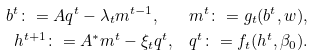Convert formula to latex. <formula><loc_0><loc_0><loc_500><loc_500>b ^ { t } \colon = A q ^ { t } - \lambda _ { t } m ^ { t - 1 } , \quad & m ^ { t } \colon = g _ { t } ( b ^ { t } , w ) , \\ h ^ { t + 1 } \colon = A ^ { * } m ^ { t } - \xi _ { t } q ^ { t } , \quad & q ^ { t } \colon = f _ { t } ( h ^ { t } , \beta _ { 0 } ) .</formula> 